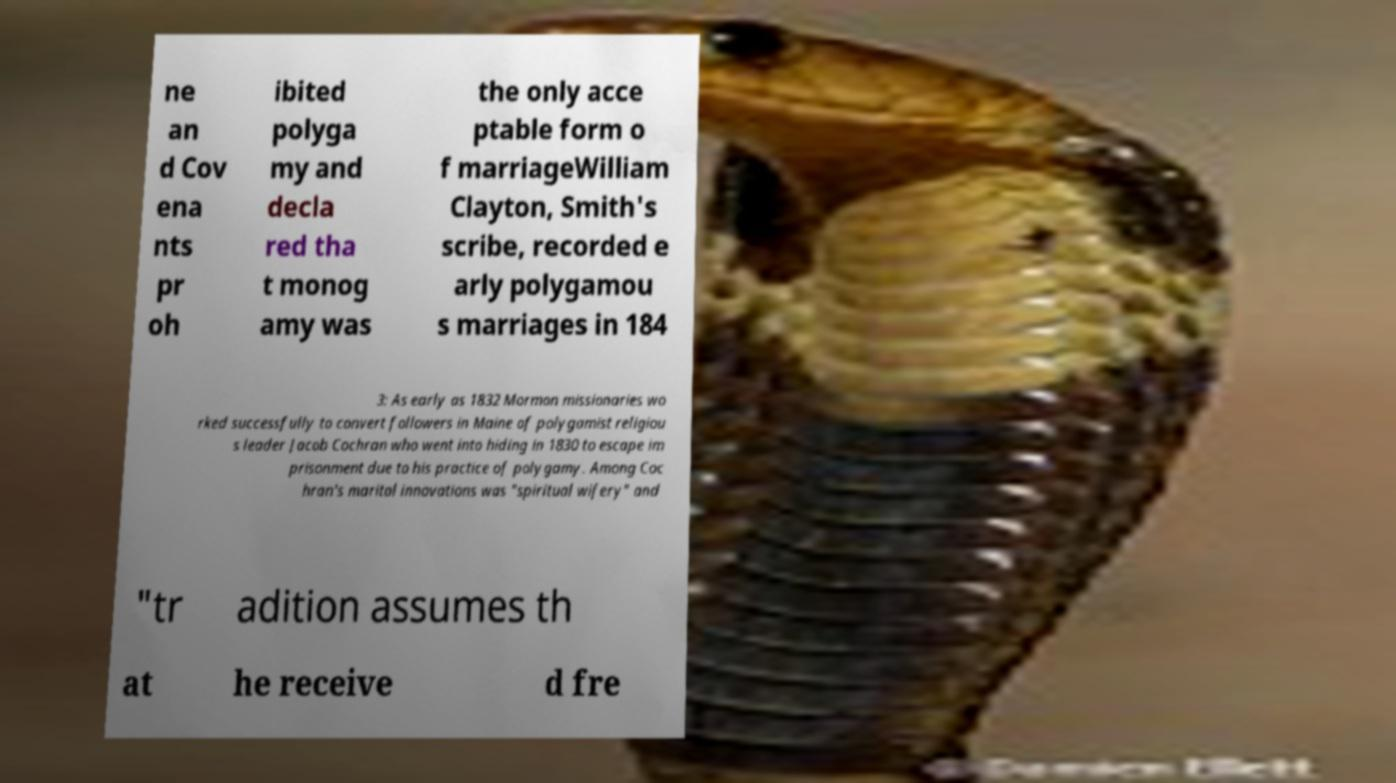Please identify and transcribe the text found in this image. ne an d Cov ena nts pr oh ibited polyga my and decla red tha t monog amy was the only acce ptable form o f marriageWilliam Clayton, Smith's scribe, recorded e arly polygamou s marriages in 184 3: As early as 1832 Mormon missionaries wo rked successfully to convert followers in Maine of polygamist religiou s leader Jacob Cochran who went into hiding in 1830 to escape im prisonment due to his practice of polygamy. Among Coc hran's marital innovations was "spiritual wifery" and "tr adition assumes th at he receive d fre 